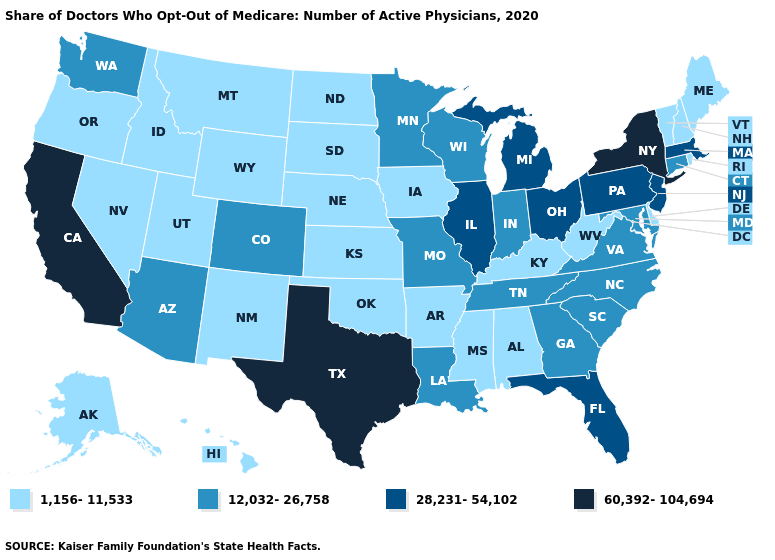Name the states that have a value in the range 28,231-54,102?
Keep it brief. Florida, Illinois, Massachusetts, Michigan, New Jersey, Ohio, Pennsylvania. Does Iowa have the lowest value in the USA?
Concise answer only. Yes. Which states have the lowest value in the West?
Give a very brief answer. Alaska, Hawaii, Idaho, Montana, Nevada, New Mexico, Oregon, Utah, Wyoming. What is the value of Oklahoma?
Keep it brief. 1,156-11,533. What is the value of Rhode Island?
Quick response, please. 1,156-11,533. Does the map have missing data?
Write a very short answer. No. Does Texas have the highest value in the USA?
Be succinct. Yes. What is the highest value in the MidWest ?
Write a very short answer. 28,231-54,102. Among the states that border Idaho , does Oregon have the highest value?
Keep it brief. No. Does Tennessee have the lowest value in the USA?
Be succinct. No. Name the states that have a value in the range 28,231-54,102?
Keep it brief. Florida, Illinois, Massachusetts, Michigan, New Jersey, Ohio, Pennsylvania. Among the states that border Vermont , which have the lowest value?
Answer briefly. New Hampshire. Name the states that have a value in the range 1,156-11,533?
Be succinct. Alabama, Alaska, Arkansas, Delaware, Hawaii, Idaho, Iowa, Kansas, Kentucky, Maine, Mississippi, Montana, Nebraska, Nevada, New Hampshire, New Mexico, North Dakota, Oklahoma, Oregon, Rhode Island, South Dakota, Utah, Vermont, West Virginia, Wyoming. What is the highest value in the South ?
Concise answer only. 60,392-104,694. 